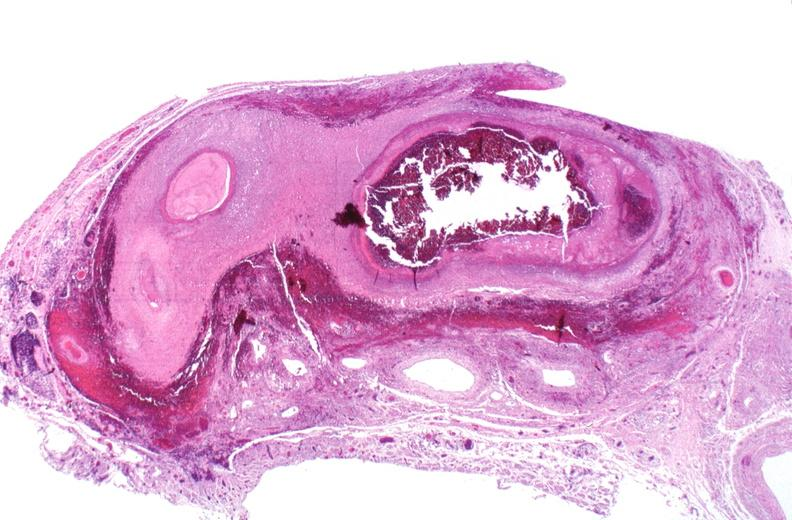s cardiovascular present?
Answer the question using a single word or phrase. Yes 